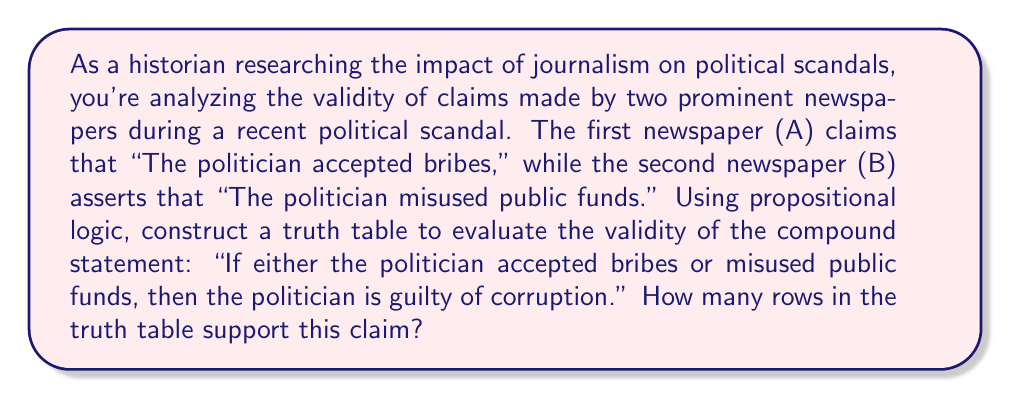Could you help me with this problem? Let's approach this step-by-step:

1) First, we need to define our propositions:
   $p$: The politician accepted bribes
   $q$: The politician misused public funds
   $r$: The politician is guilty of corruption

2) The compound statement can be represented as:
   $(p \lor q) \rightarrow r$

3) To construct the truth table, we need columns for $p$, $q$, $r$, $(p \lor q)$, and $(p \lor q) \rightarrow r$

4) The truth table will have $2^3 = 8$ rows (as we have 3 variables)

5) Let's construct the truth table:

   $$
   \begin{array}{|c|c|c|c|c|}
   \hline
   p & q & r & p \lor q & (p \lor q) \rightarrow r \\
   \hline
   T & T & T & T & T \\
   T & T & F & T & F \\
   T & F & T & T & T \\
   T & F & F & T & F \\
   F & T & T & T & T \\
   F & T & F & T & F \\
   F & F & T & F & T \\
   F & F & F & F & T \\
   \hline
   \end{array}
   $$

6) The compound statement $(p \lor q) \rightarrow r$ is true when:
   - $p \lor q$ is false (last row)
   - $r$ is true (rows 1, 3, 5, 7)

7) Counting these rows, we see that the statement is true in 5 out of 8 rows.

Therefore, 5 rows in the truth table support the claim that "If either the politician accepted bribes or misused public funds, then the politician is guilty of corruption."
Answer: 5 rows 